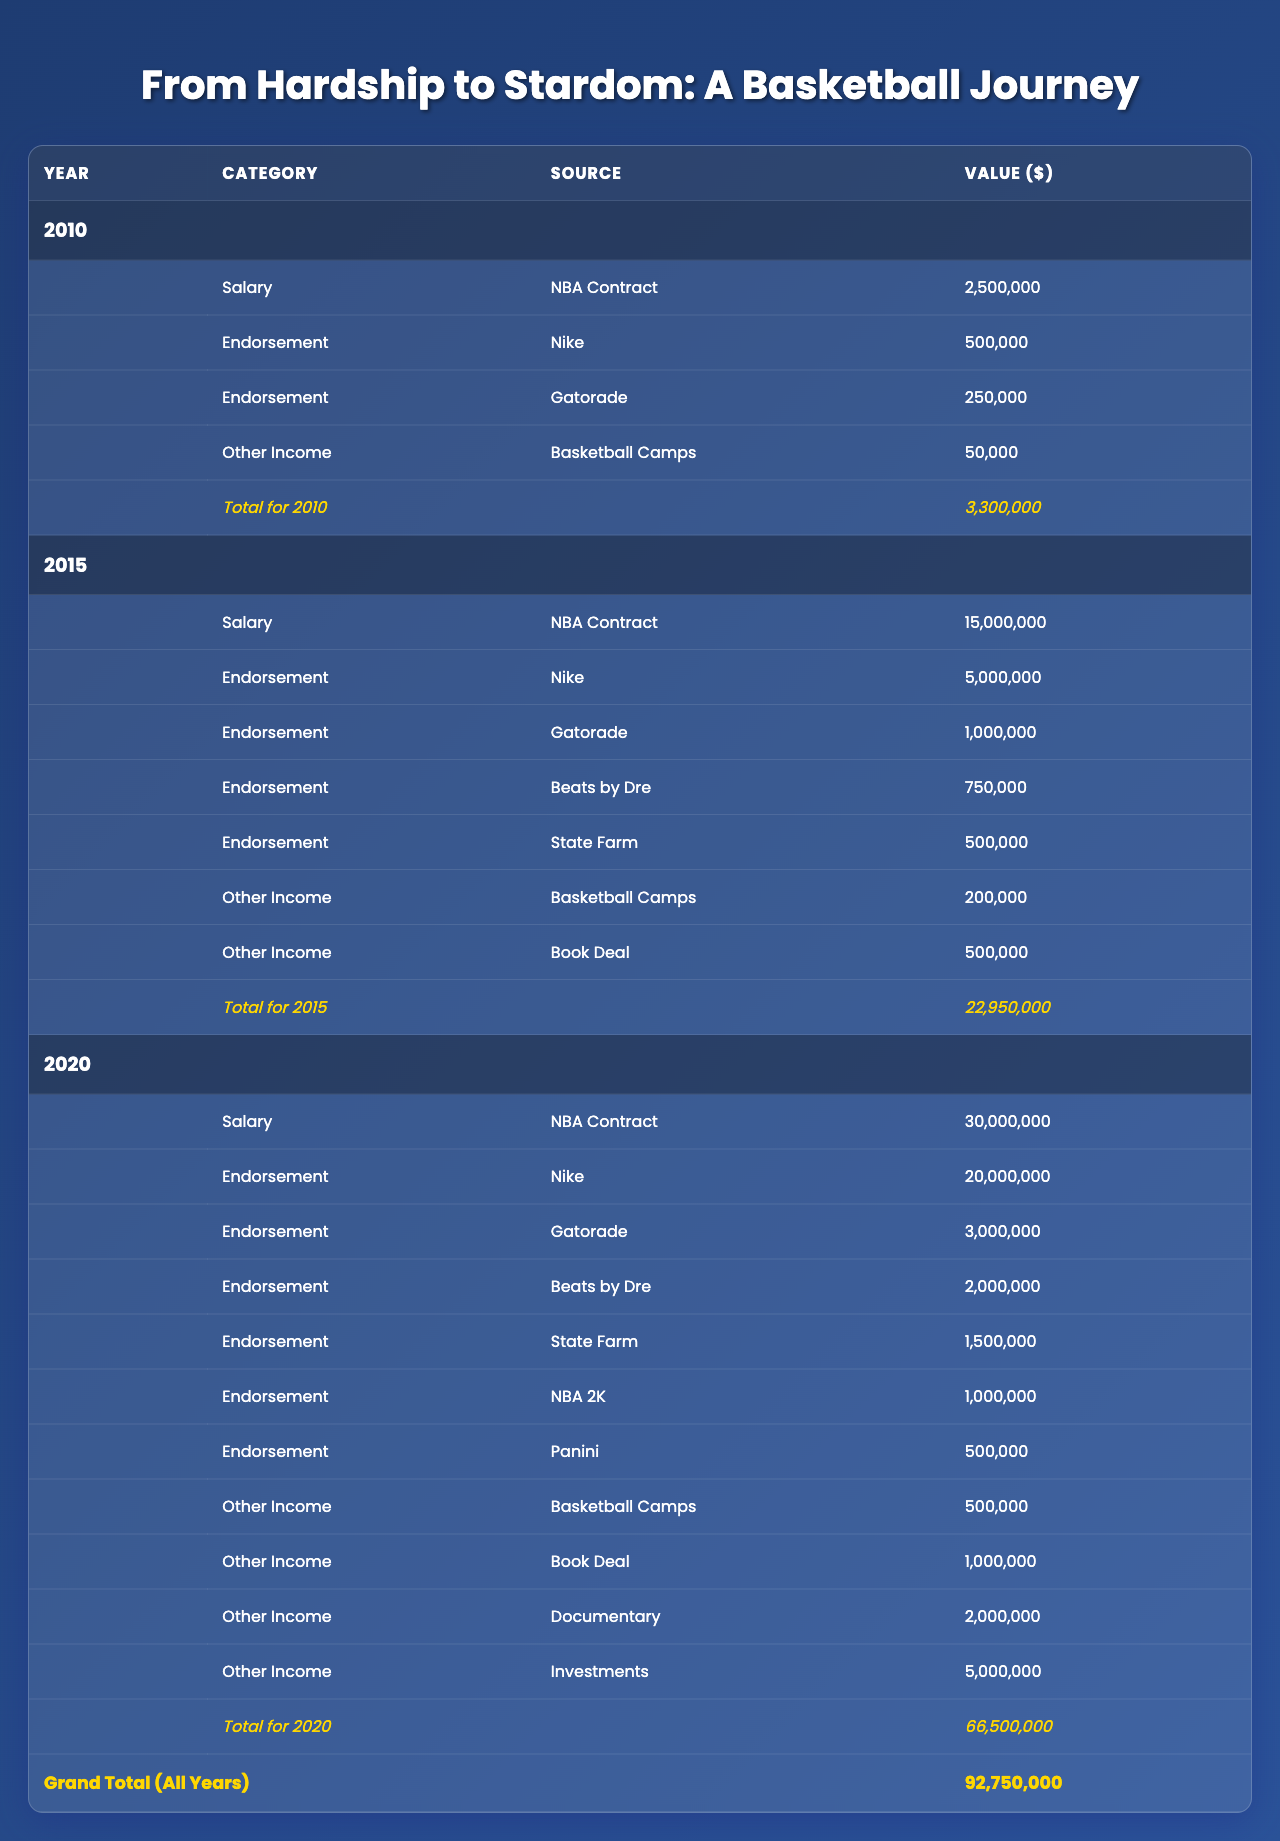What was the salary in 2015? The salary for the year 2015 is listed directly in the table. It shows a value of $15,000,000.
Answer: $15,000,000 Which endorsement provided the highest revenue in 2020? In the year 2020, the endorsement from Nike provided the highest revenue, amounting to $20,000,000.
Answer: Nike What is the total income from endorsements in 2010? In 2010, the endorsements were from Nike ($500,000) and Gatorade ($250,000). The total is calculated as $500,000 + $250,000 = $750,000.
Answer: $750,000 Did the total revenue increase every year from 2010 to 2020? By checking the total revenues for each year: 2010 ($2,500,000), 2015 ($16,200,000), and 2020 ($34,500,000), it's evident that total revenue increased every year.
Answer: Yes What was the combined value of all endorsement deals in 2015? In 2015, the endorsement values were Nike ($5,000,000), Gatorade ($1,000,000), Beats by Dre ($750,000), and State Farm ($500,000). The combined value is $5,000,000 + $1,000,000 + $750,000 + $500,000 = $7,250,000.
Answer: $7,250,000 How much did the income from basketball camps change from 2010 to 2020? The income from basketball camps in 2010 was $50,000, and in 2020 it was $500,000. The difference is calculated as $500,000 - $50,000 = $450,000, indicating an increase.
Answer: Increased by $450,000 What was the grand total of all revenues over the three years? The grand totals for each year are: 2010 ($2,500,000), 2015 ($16,200,000), and 2020 ($34,500,000). Adding those gives $2,500,000 + $16,200,000 + $34,500,000 = $53,200,000.
Answer: $53,200,000 Which other income source contributed the most in 2020? The other income sources in 2020 were Basketball Camps ($500,000), Book Deal ($1,000,000), Documentary ($2,000,000), and Investments ($5,000,000). The highest contribution was from Investments, totaling $5,000,000.
Answer: Investments In which year was the combined income from endorsements and other income the highest? The total income from endorsements and other income per year is as follows: 2010: $750,000 + $2,500,000 = $3,250,000, 2015: $7,250,000 + $15,000,000 = $22,250,000, and 2020: $34,500,000 from total. Thus, 2020 had the highest combined income.
Answer: 2020 What percentage of total revenue in 2020 came from endorsements? The total revenue in 2020 is $34,500,000, and the endorsement total is $30,000,000. The percentage is calculated as ($30,000,000 / $34,500,000) * 100 = 86.96%.
Answer: 86.96% 